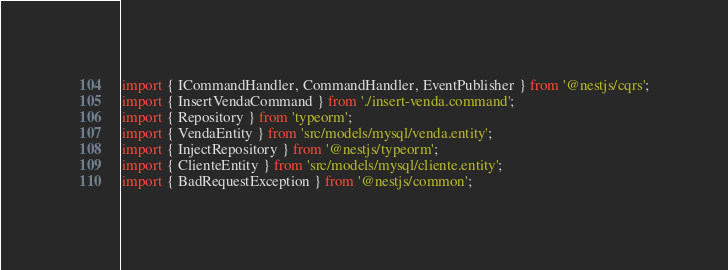<code> <loc_0><loc_0><loc_500><loc_500><_TypeScript_>import { ICommandHandler, CommandHandler, EventPublisher } from '@nestjs/cqrs';
import { InsertVendaCommand } from './insert-venda.command';
import { Repository } from 'typeorm';
import { VendaEntity } from 'src/models/mysql/venda.entity';
import { InjectRepository } from '@nestjs/typeorm';
import { ClienteEntity } from 'src/models/mysql/cliente.entity';
import { BadRequestException } from '@nestjs/common';</code> 